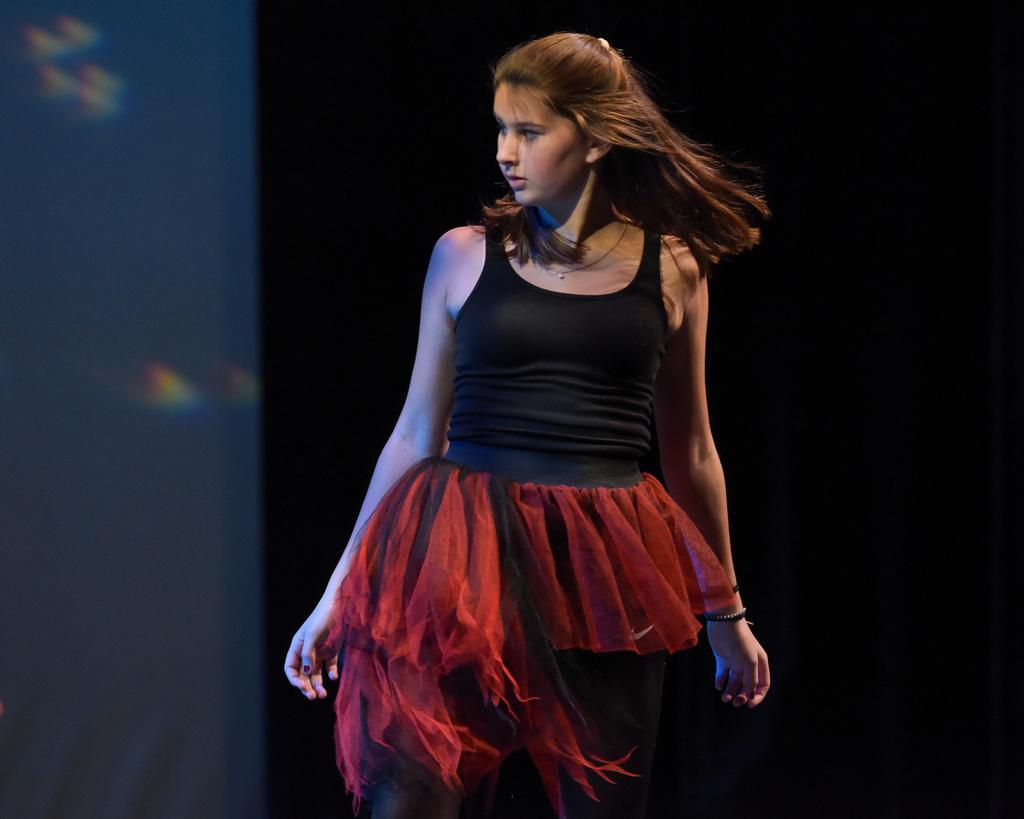Describe this image in one or two sentences. In this image I can see a woman. The background is black in color. 